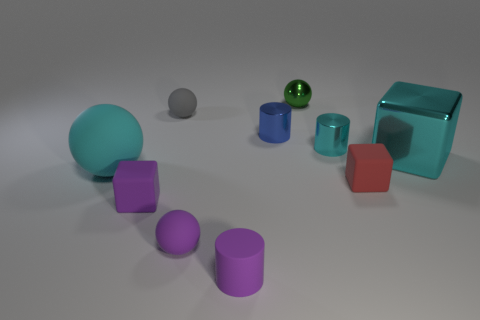Subtract all tiny red cubes. How many cubes are left? 2 Subtract all cyan balls. How many balls are left? 3 Subtract all red spheres. How many purple cubes are left? 1 Add 1 red objects. How many red objects are left? 2 Add 1 metal spheres. How many metal spheres exist? 2 Subtract 0 green cylinders. How many objects are left? 10 Subtract all cubes. How many objects are left? 7 Subtract 1 cubes. How many cubes are left? 2 Subtract all gray balls. Subtract all gray cubes. How many balls are left? 3 Subtract all cyan things. Subtract all cyan rubber balls. How many objects are left? 6 